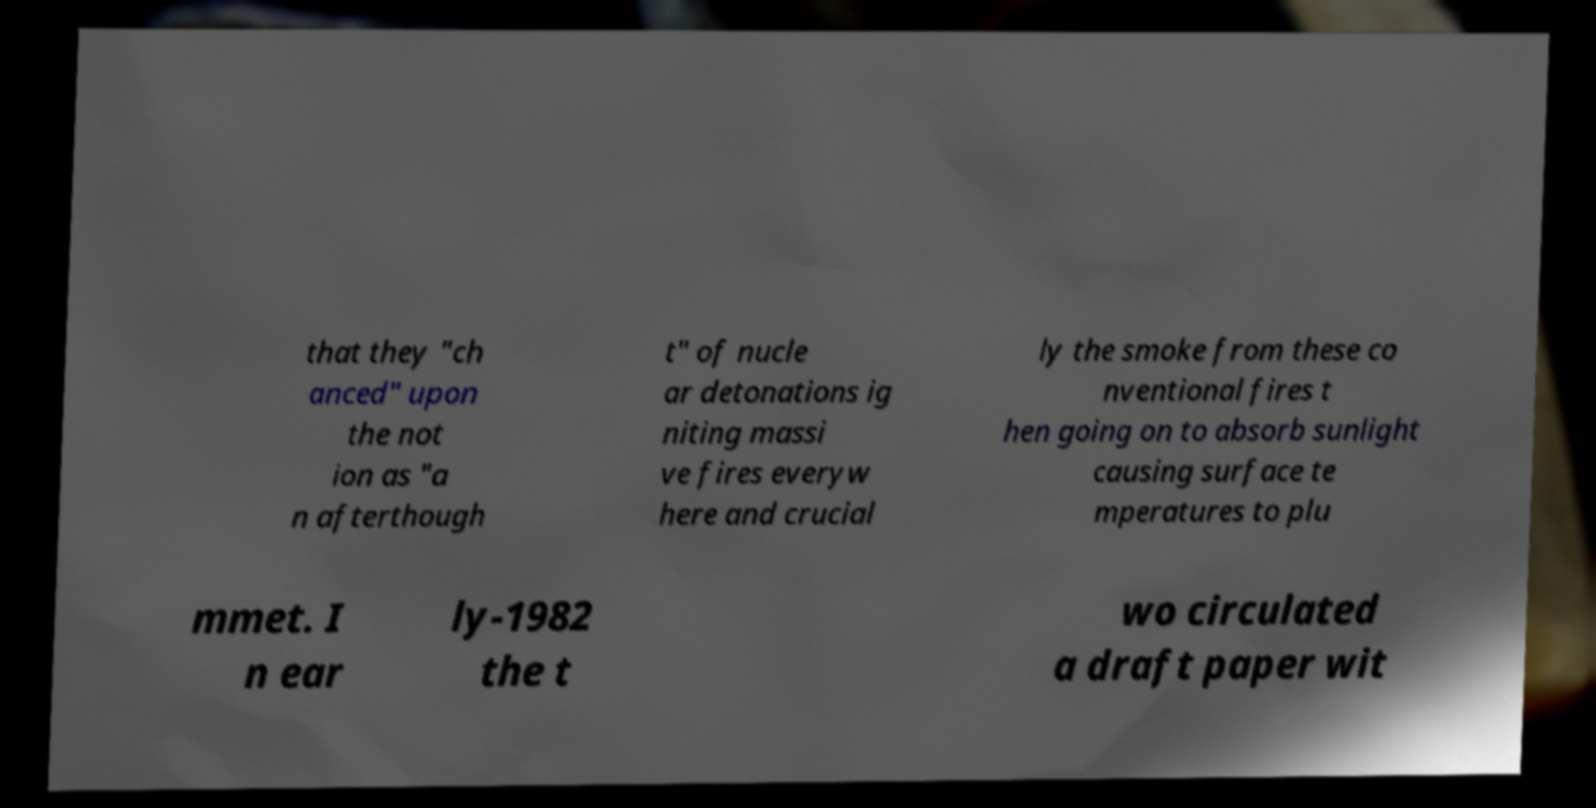I need the written content from this picture converted into text. Can you do that? that they "ch anced" upon the not ion as "a n afterthough t" of nucle ar detonations ig niting massi ve fires everyw here and crucial ly the smoke from these co nventional fires t hen going on to absorb sunlight causing surface te mperatures to plu mmet. I n ear ly-1982 the t wo circulated a draft paper wit 